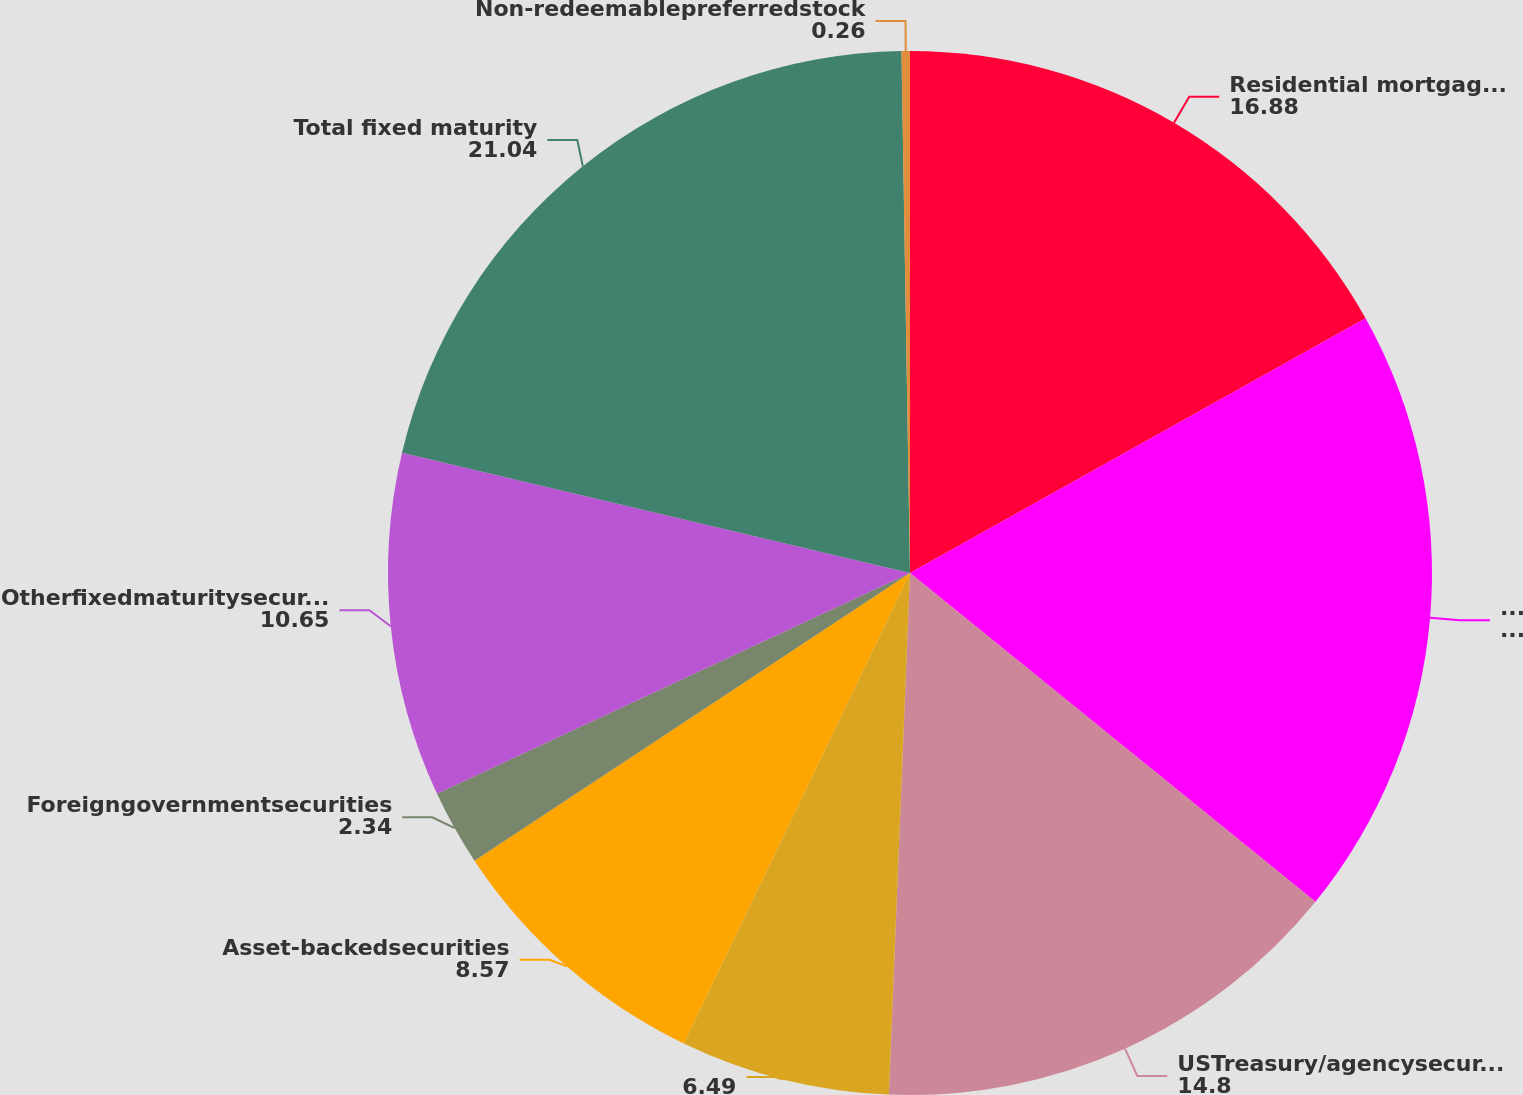<chart> <loc_0><loc_0><loc_500><loc_500><pie_chart><fcel>Residential mortgage-backed<fcel>Foreigncorporatesecurities<fcel>USTreasury/agencysecurities<fcel>Unnamed: 3<fcel>Asset-backedsecurities<fcel>Foreigngovernmentsecurities<fcel>Otherfixedmaturitysecurities<fcel>Total fixed maturity<fcel>Non-redeemablepreferredstock<nl><fcel>16.88%<fcel>18.96%<fcel>14.8%<fcel>6.49%<fcel>8.57%<fcel>2.34%<fcel>10.65%<fcel>21.04%<fcel>0.26%<nl></chart> 